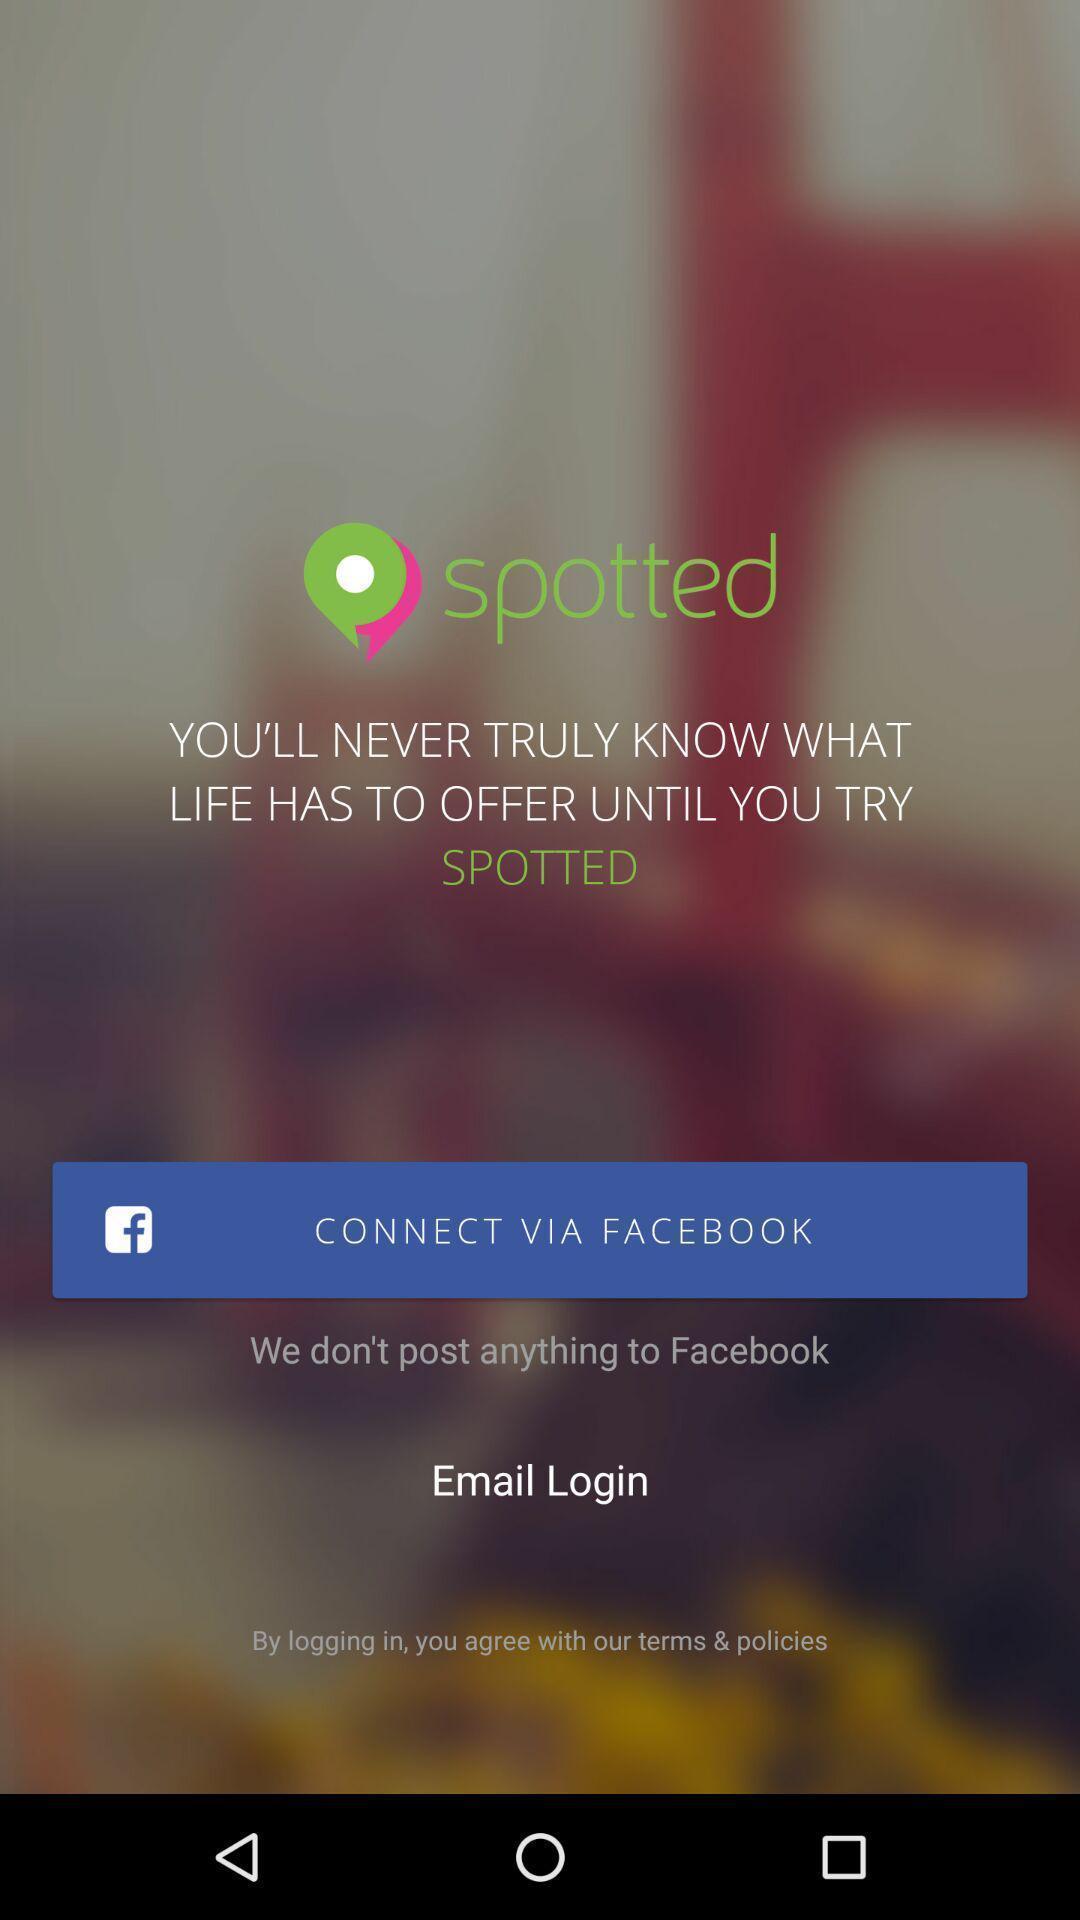Tell me what you see in this picture. Welcome page of a social app. 